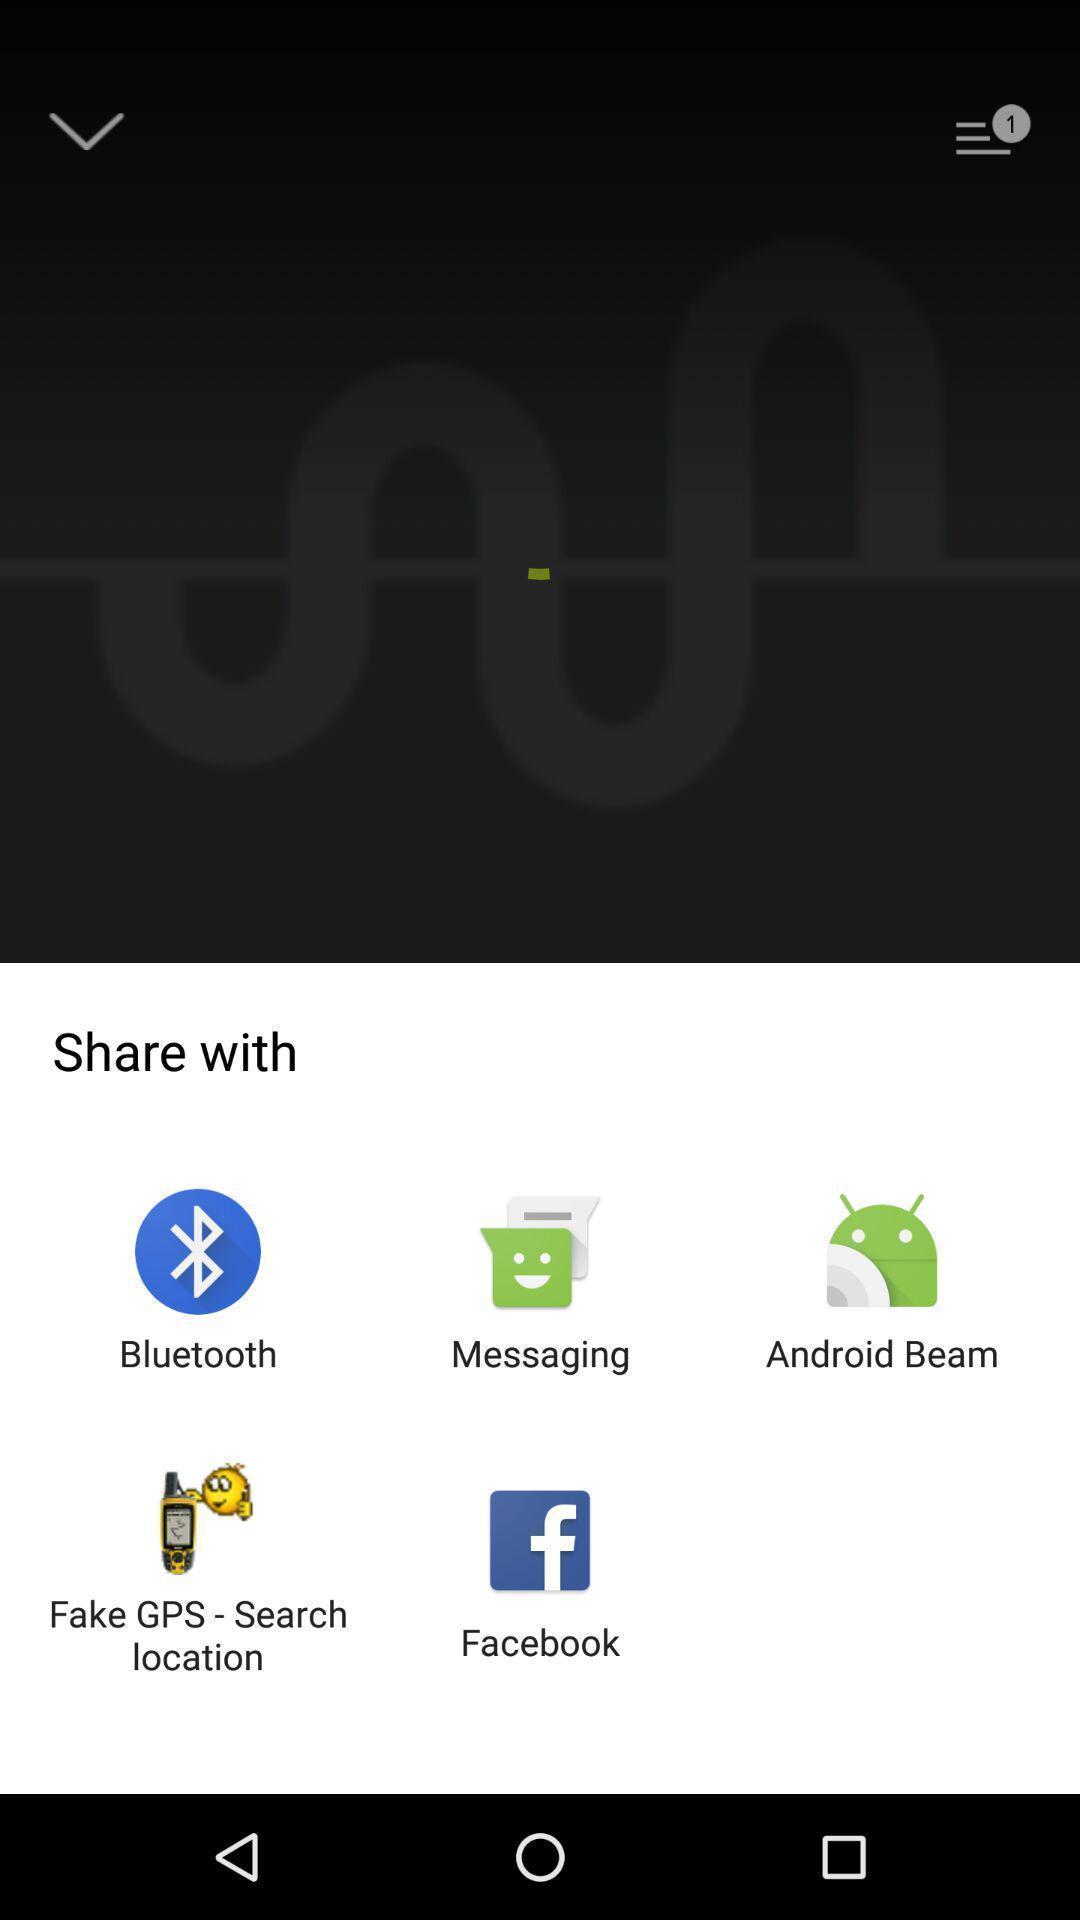Explain what's happening in this screen capture. Push up notification with multiple sharing options. 